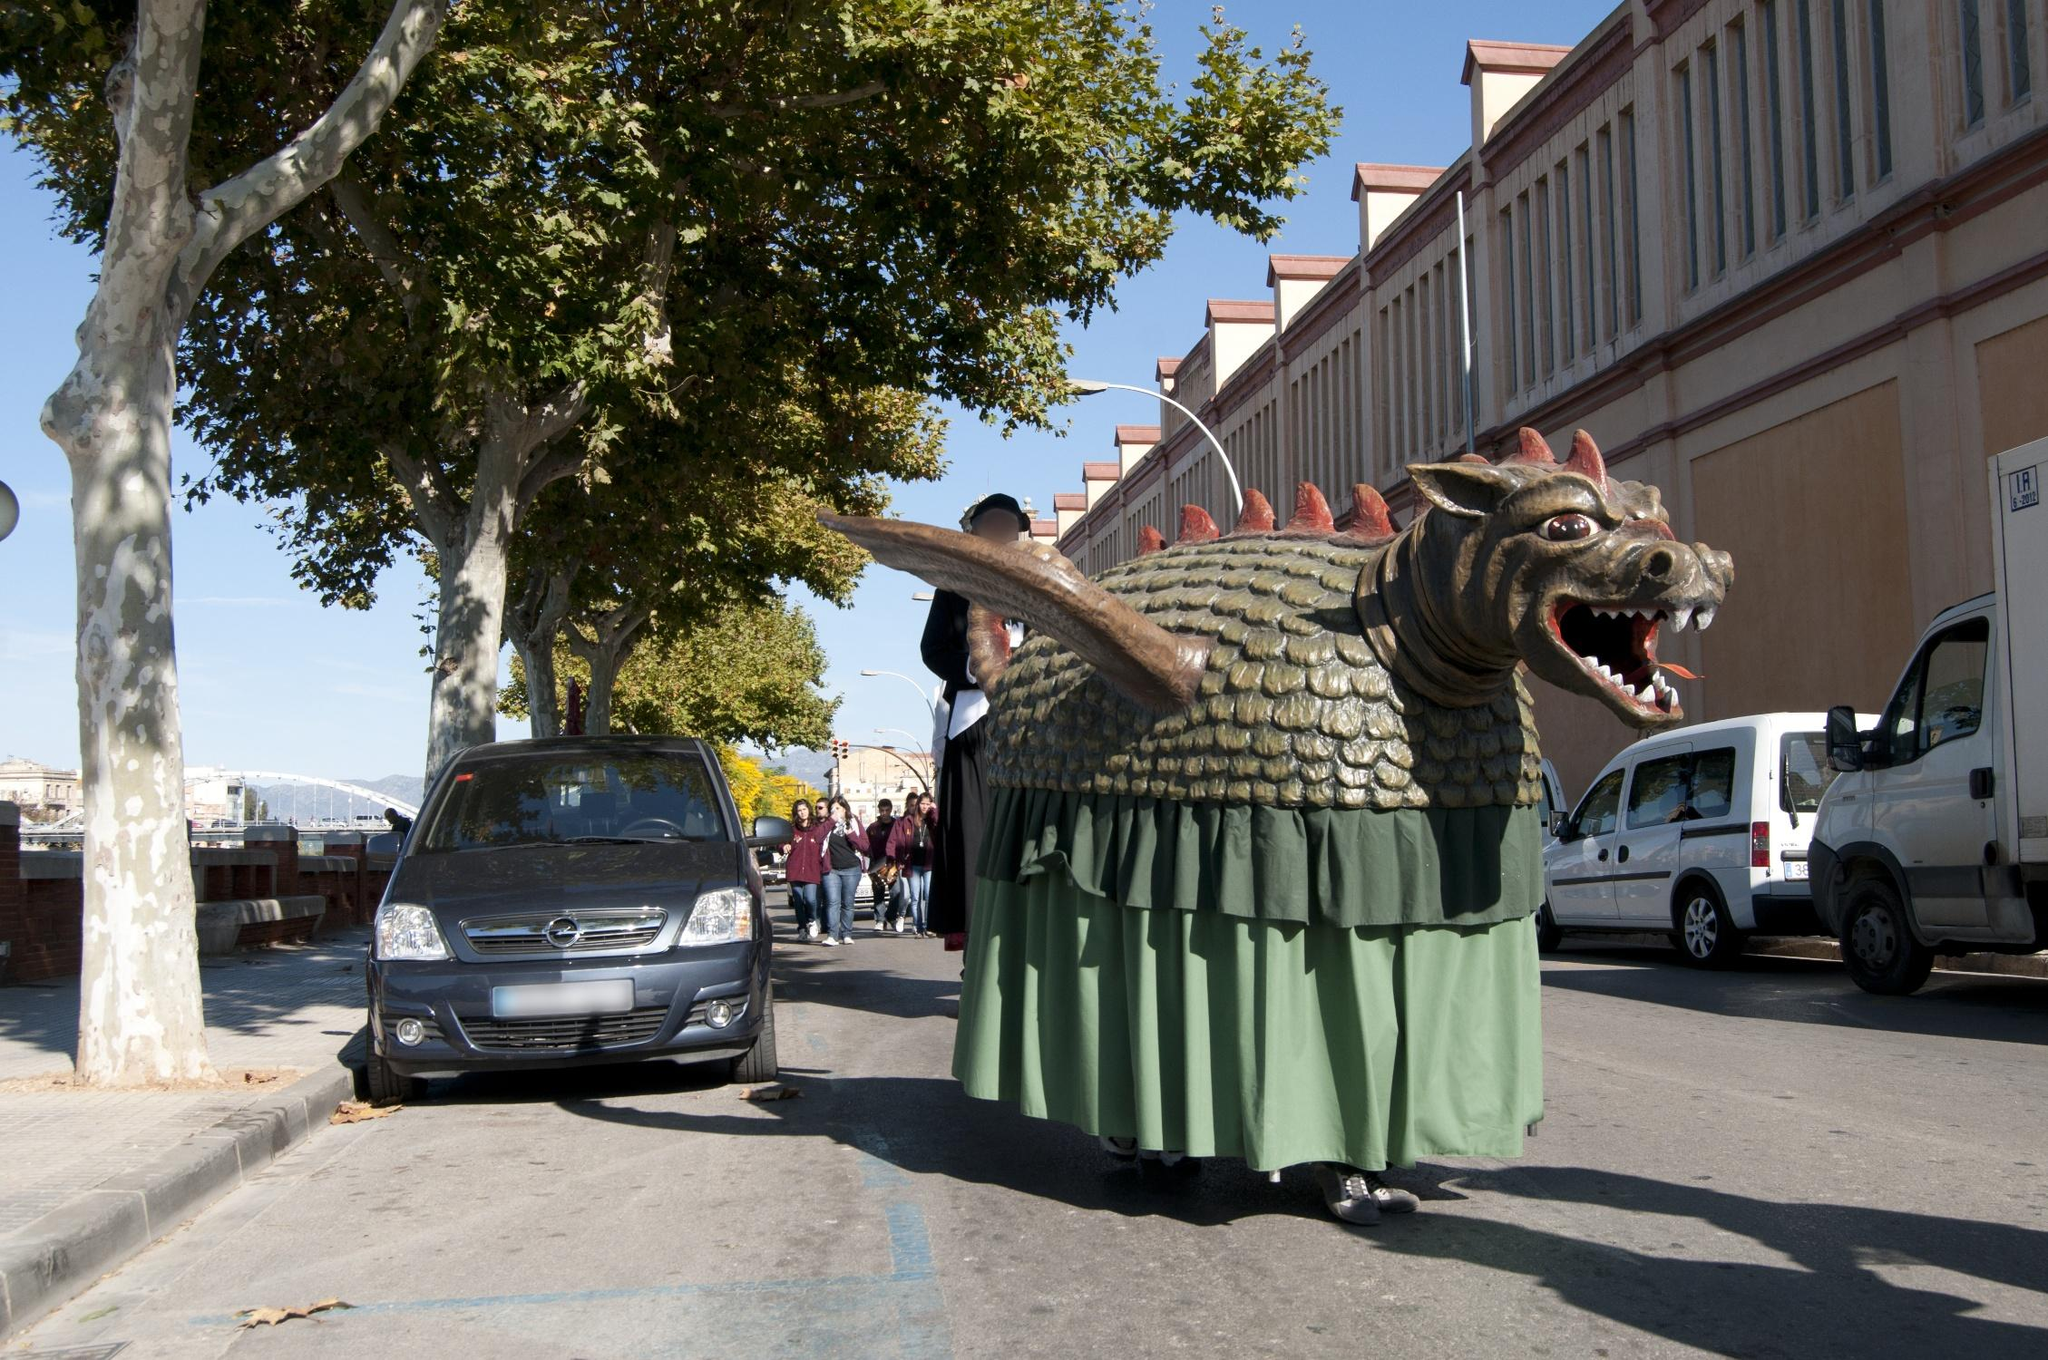Could this dragon have a hidden meaning or story behind its creation? Absolutely! The dragon could be based on the legendary Catalan dragon, known as 'Drac'. In historical folklore, Drac is often depicted as a mighty and protective creature, symbolizing strength, bravery, and the spirit of resilience. The float's design might be inspired by ancient stories and artistic traditions passed down through generations. It could also signify the local community's connection to their mythical past and their pride in preserving and celebrating their heritage through such elaborate displays during festivities. Can you tell a fictional short story inspired by this dragon? Once upon a time, in the heart of Barcelona, there lived a dragon named Arcos. Unlike other dragons, Arcos was not a fearsome creature but a guardian of joy and festivity. Every year, during the grand festival, Arcos would awaken from his slumber beneath the city, drawn by the vibrant, jubilant atmosphere above.

One year, as the festival was about to begin, the city was struck by an unusual stillness. The people were troubled; a mysterious darkness had crept over the city, dampening their spirits. Sensing the melancholy, Arcos decided to rise from his hidden lair, determined to restore joy to the streets of Barcelona.

As Arcos emerged, his scales glittered like emeralds in the sunlight, his presence immediately lifting the gloom. The people watched in awe as the gentle giant unfurled his massive wings and breathed out a radiant, golden light that illuminated every corner of the city. With every step Arcos took, laughter and music followed, revitalizing the festive spirit of La Mercè.

Children danced around Arcos, captivated by his friendly demeanor and ancient tales of bravery and hope. The city came alive with a renewed sense of community and celebration, united by the dragon's magical influence. Arcos, seeing the joy restored, returned to his rest, knowing he had once again fulfilled his duty as Barcelona's watchful guardian.

From that day forward, the people of Barcelona cherished the legend of Arcos, celebrating the dragon's legacy of joy and unity every year, keeping his spirit alive in their hearts and their festival's grandest float. What other creatures might accompany the dragon in the festival? Other creatures that might accompany the dragon in the festival could include whimsical devils, known as 'diables', who dance and emit sparks from their pitchforks, adding a dynamic and fiery element to the parade. Giant eagles and lions, representing noble virtues and local legends, might also be part of the spectacle, each float meticulously crafted and richly decorated. There could be gigantes, giant figures representing historical and mythical characters, towering over the crowd and moving gracefully. Smaller, playful creatures like dwarfs or 'nanets' might also participate, engaging with the crowd and adding to the joy and merriment of the festival. All these fantastical beings collectively create an enchanting and unforgettable experience, reflecting the region's rich folklore and creative spirit. 